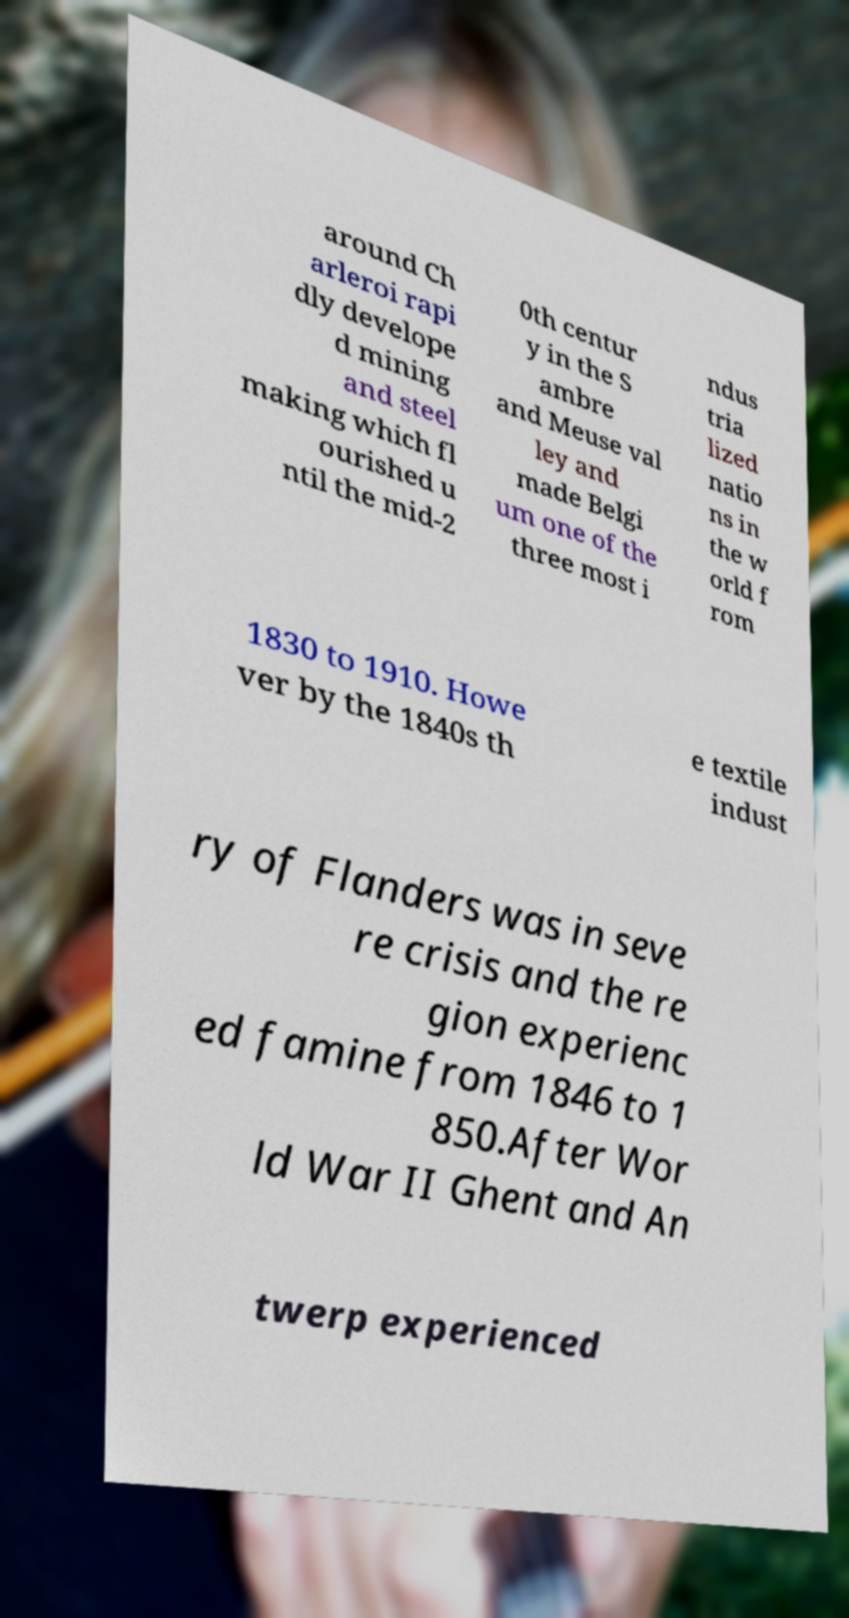Can you read and provide the text displayed in the image?This photo seems to have some interesting text. Can you extract and type it out for me? around Ch arleroi rapi dly develope d mining and steel making which fl ourished u ntil the mid-2 0th centur y in the S ambre and Meuse val ley and made Belgi um one of the three most i ndus tria lized natio ns in the w orld f rom 1830 to 1910. Howe ver by the 1840s th e textile indust ry of Flanders was in seve re crisis and the re gion experienc ed famine from 1846 to 1 850.After Wor ld War II Ghent and An twerp experienced 